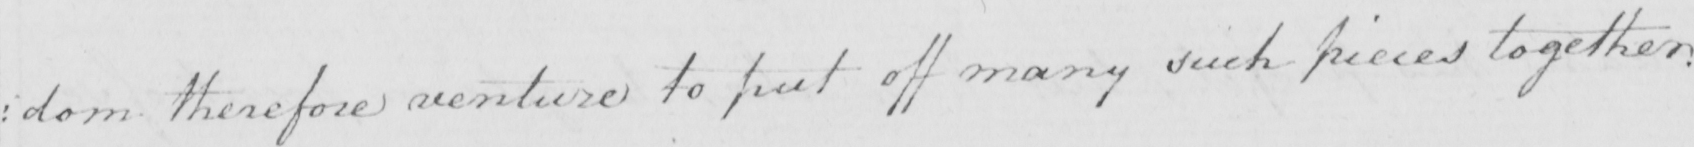What text is written in this handwritten line? : dom therefore venture to put off many such pieces together . 